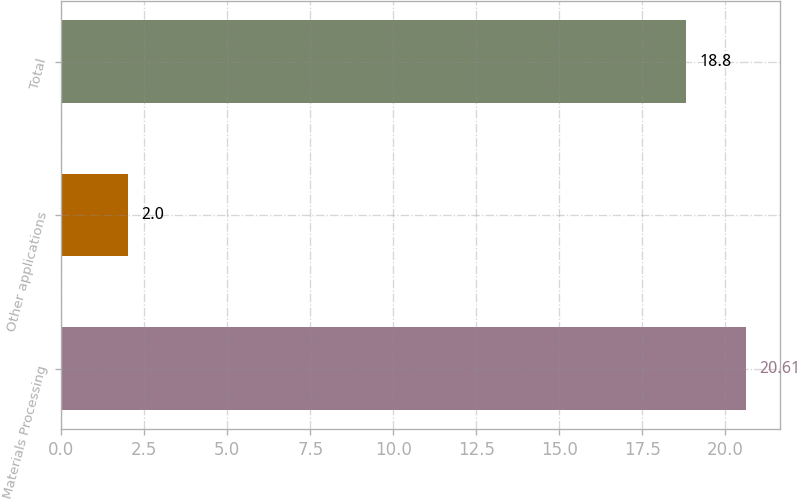Convert chart. <chart><loc_0><loc_0><loc_500><loc_500><bar_chart><fcel>Materials Processing<fcel>Other applications<fcel>Total<nl><fcel>20.61<fcel>2<fcel>18.8<nl></chart> 